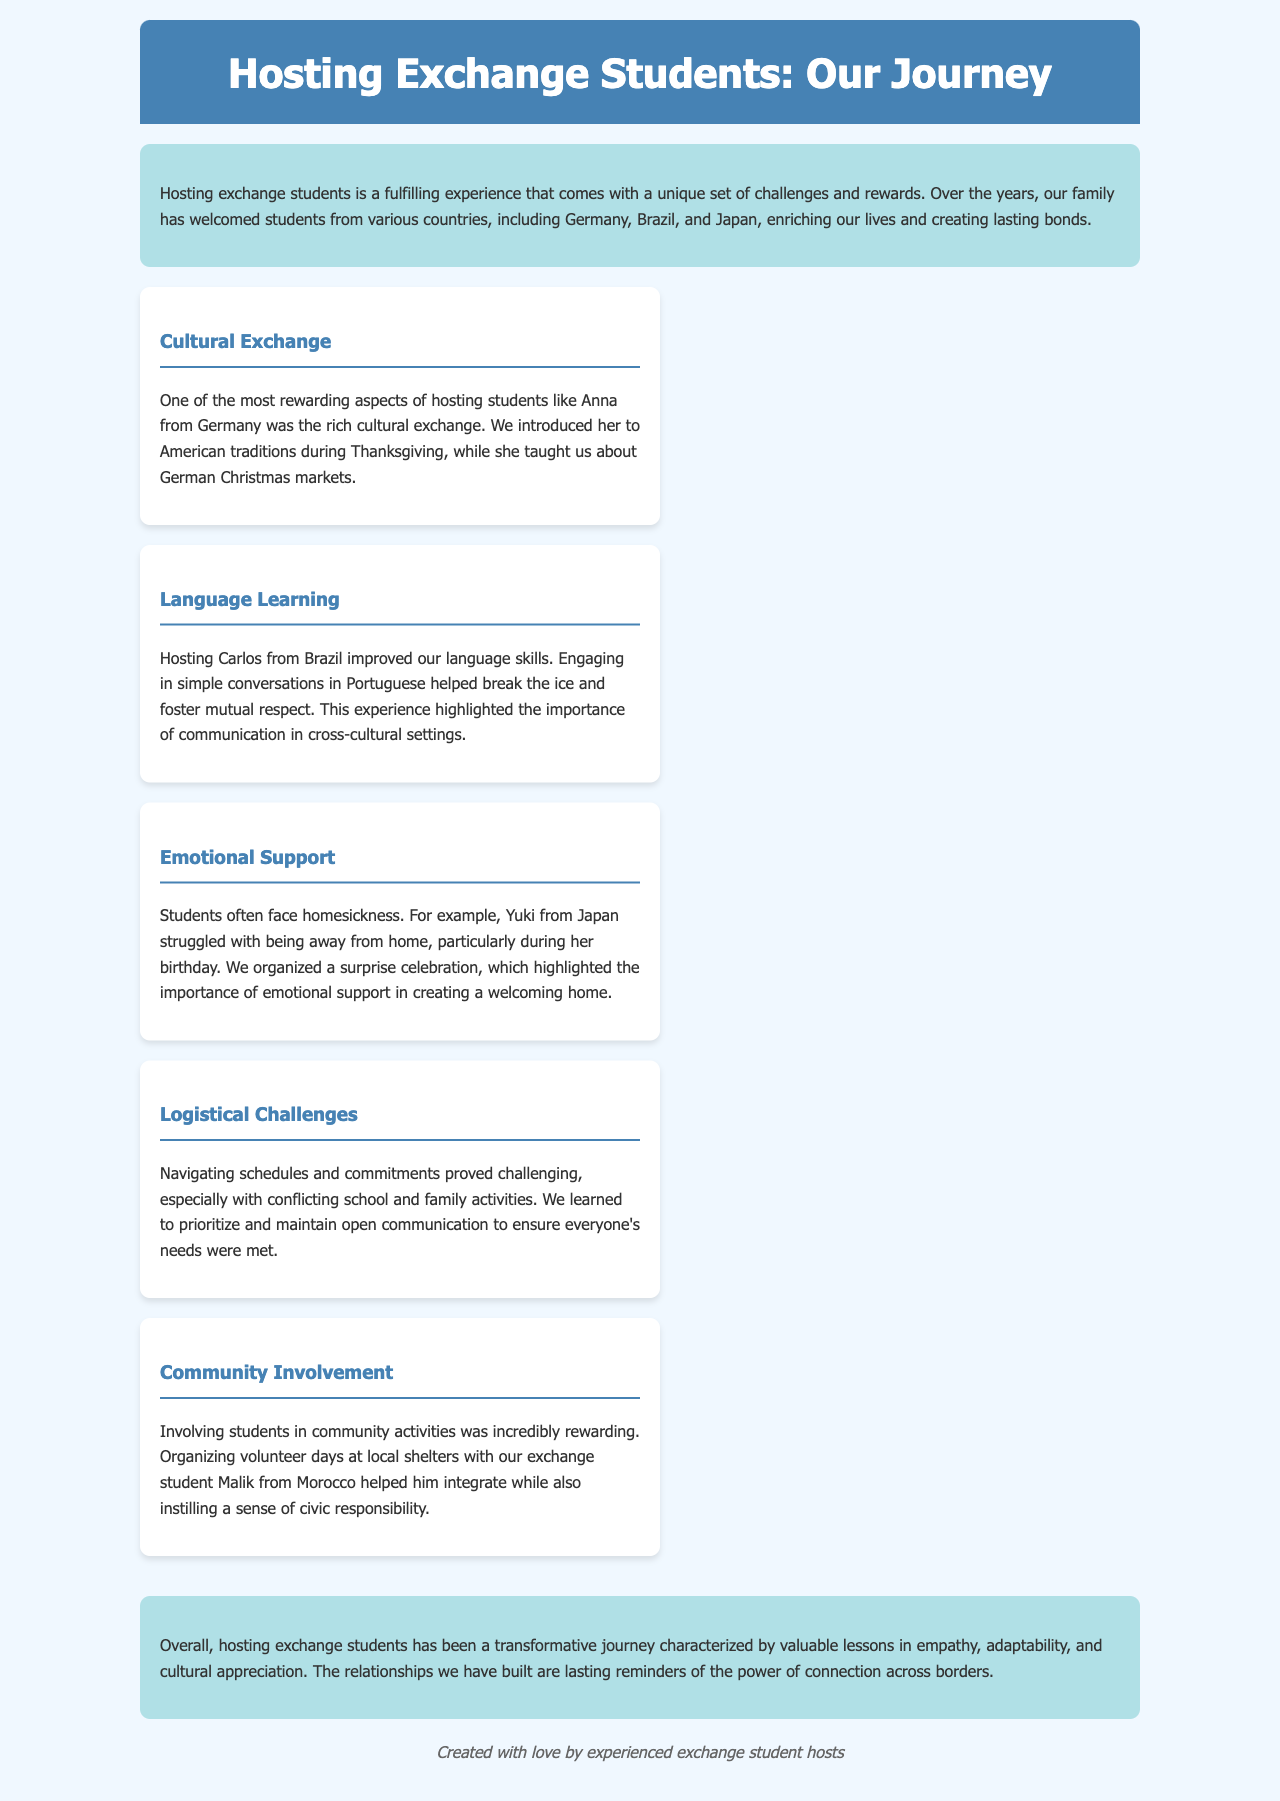what countries have the exchange students come from? The document mentions the exchange students came from Germany, Brazil, and Japan.
Answer: Germany, Brazil, Japan who reflected on cultural exchange with Anna? The experience highlights the cultural exchange with Anna from Germany.
Answer: Anna what logistical challenge did the hosts face? The document mentions navigating schedules and commitments as a logistical challenge.
Answer: Navigating schedules who faced homesickness during her birthday? Yuki from Japan struggled with homesickness, particularly during her birthday.
Answer: Yuki what type of support was highlighted when celebrating Yuki's birthday? The document emphasizes the importance of emotional support during Yuki's homesickness.
Answer: Emotional support how did community involvement benefit Malik? The document states that volunteering helped Malik integrate and instilled civic responsibility.
Answer: Integration and civic responsibility 